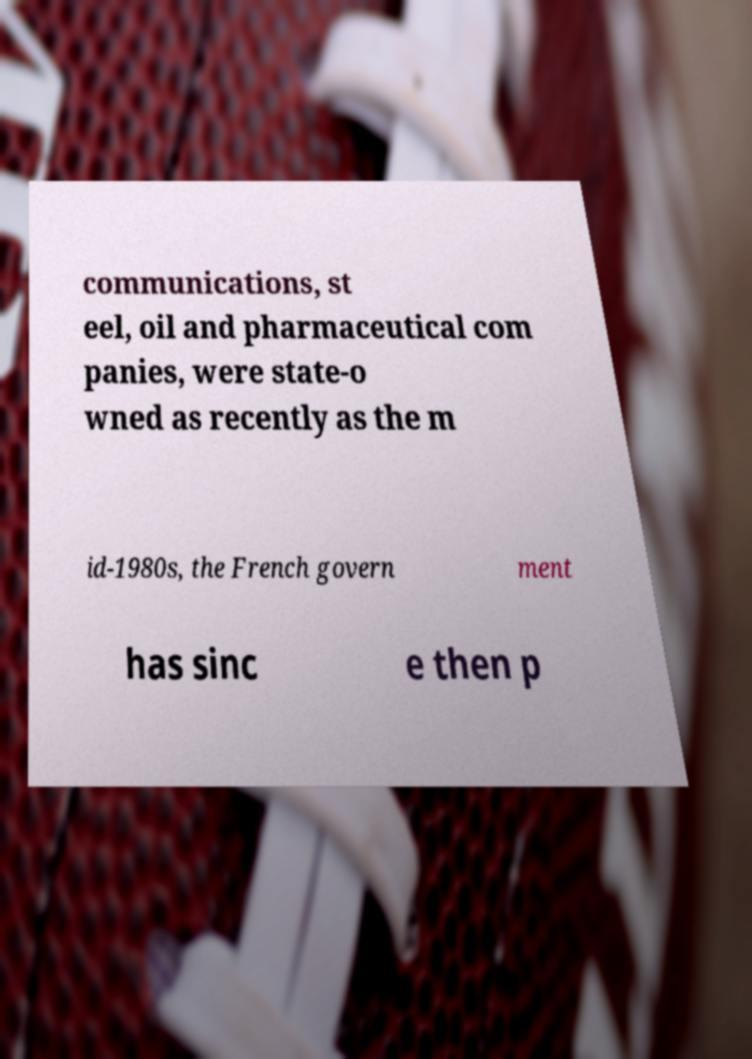Please identify and transcribe the text found in this image. communications, st eel, oil and pharmaceutical com panies, were state-o wned as recently as the m id-1980s, the French govern ment has sinc e then p 